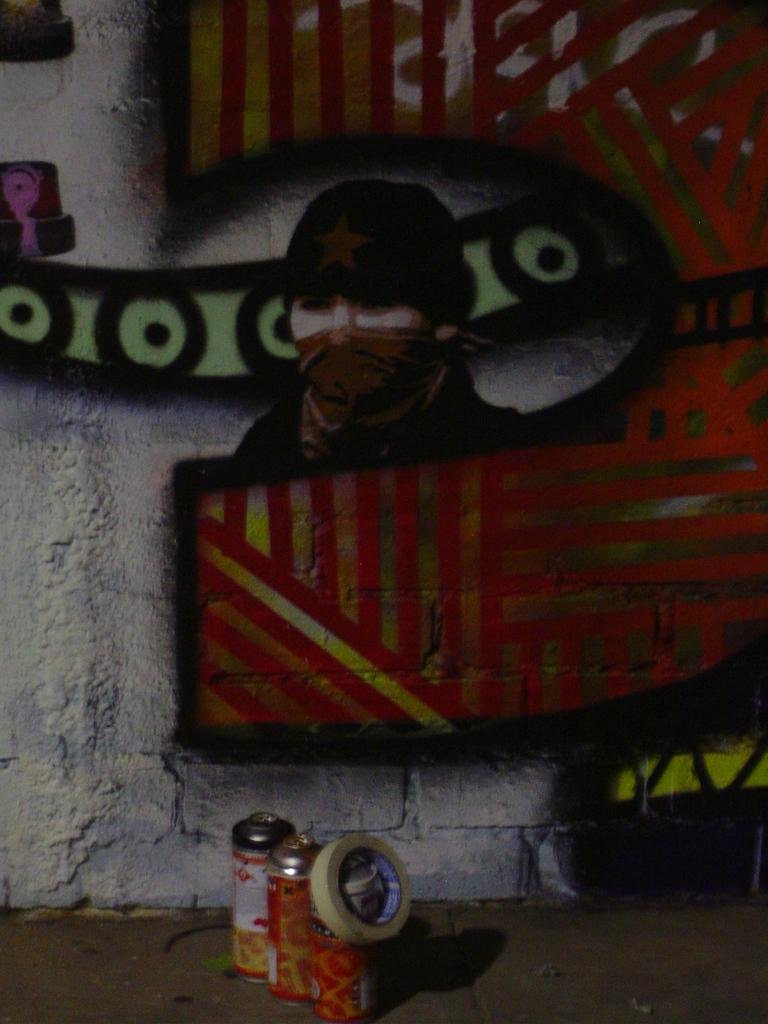What is depicted on the wall in the image? There is a graffiti painting on a wall in the image. What tools are used for creating the graffiti? Graffiti spray bottles are present in the image. Can you describe any other objects in the image? There is a plaster in the image. What type of dress is the animal wearing in the image? There is no animal or dress present in the image. 